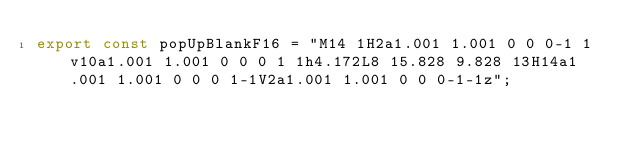<code> <loc_0><loc_0><loc_500><loc_500><_JavaScript_>export const popUpBlankF16 = "M14 1H2a1.001 1.001 0 0 0-1 1v10a1.001 1.001 0 0 0 1 1h4.172L8 15.828 9.828 13H14a1.001 1.001 0 0 0 1-1V2a1.001 1.001 0 0 0-1-1z";
</code> 